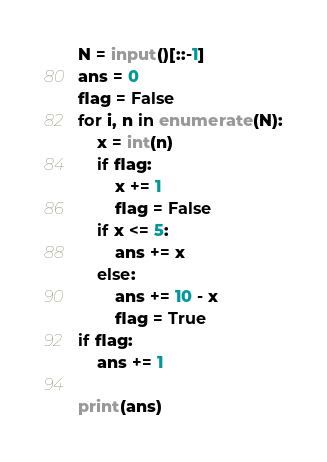<code> <loc_0><loc_0><loc_500><loc_500><_Python_>N = input()[::-1]
ans = 0
flag = False
for i, n in enumerate(N):
    x = int(n)
    if flag:
        x += 1
        flag = False
    if x <= 5:
        ans += x
    else:
        ans += 10 - x
        flag = True
if flag:
    ans += 1

print(ans)



</code> 